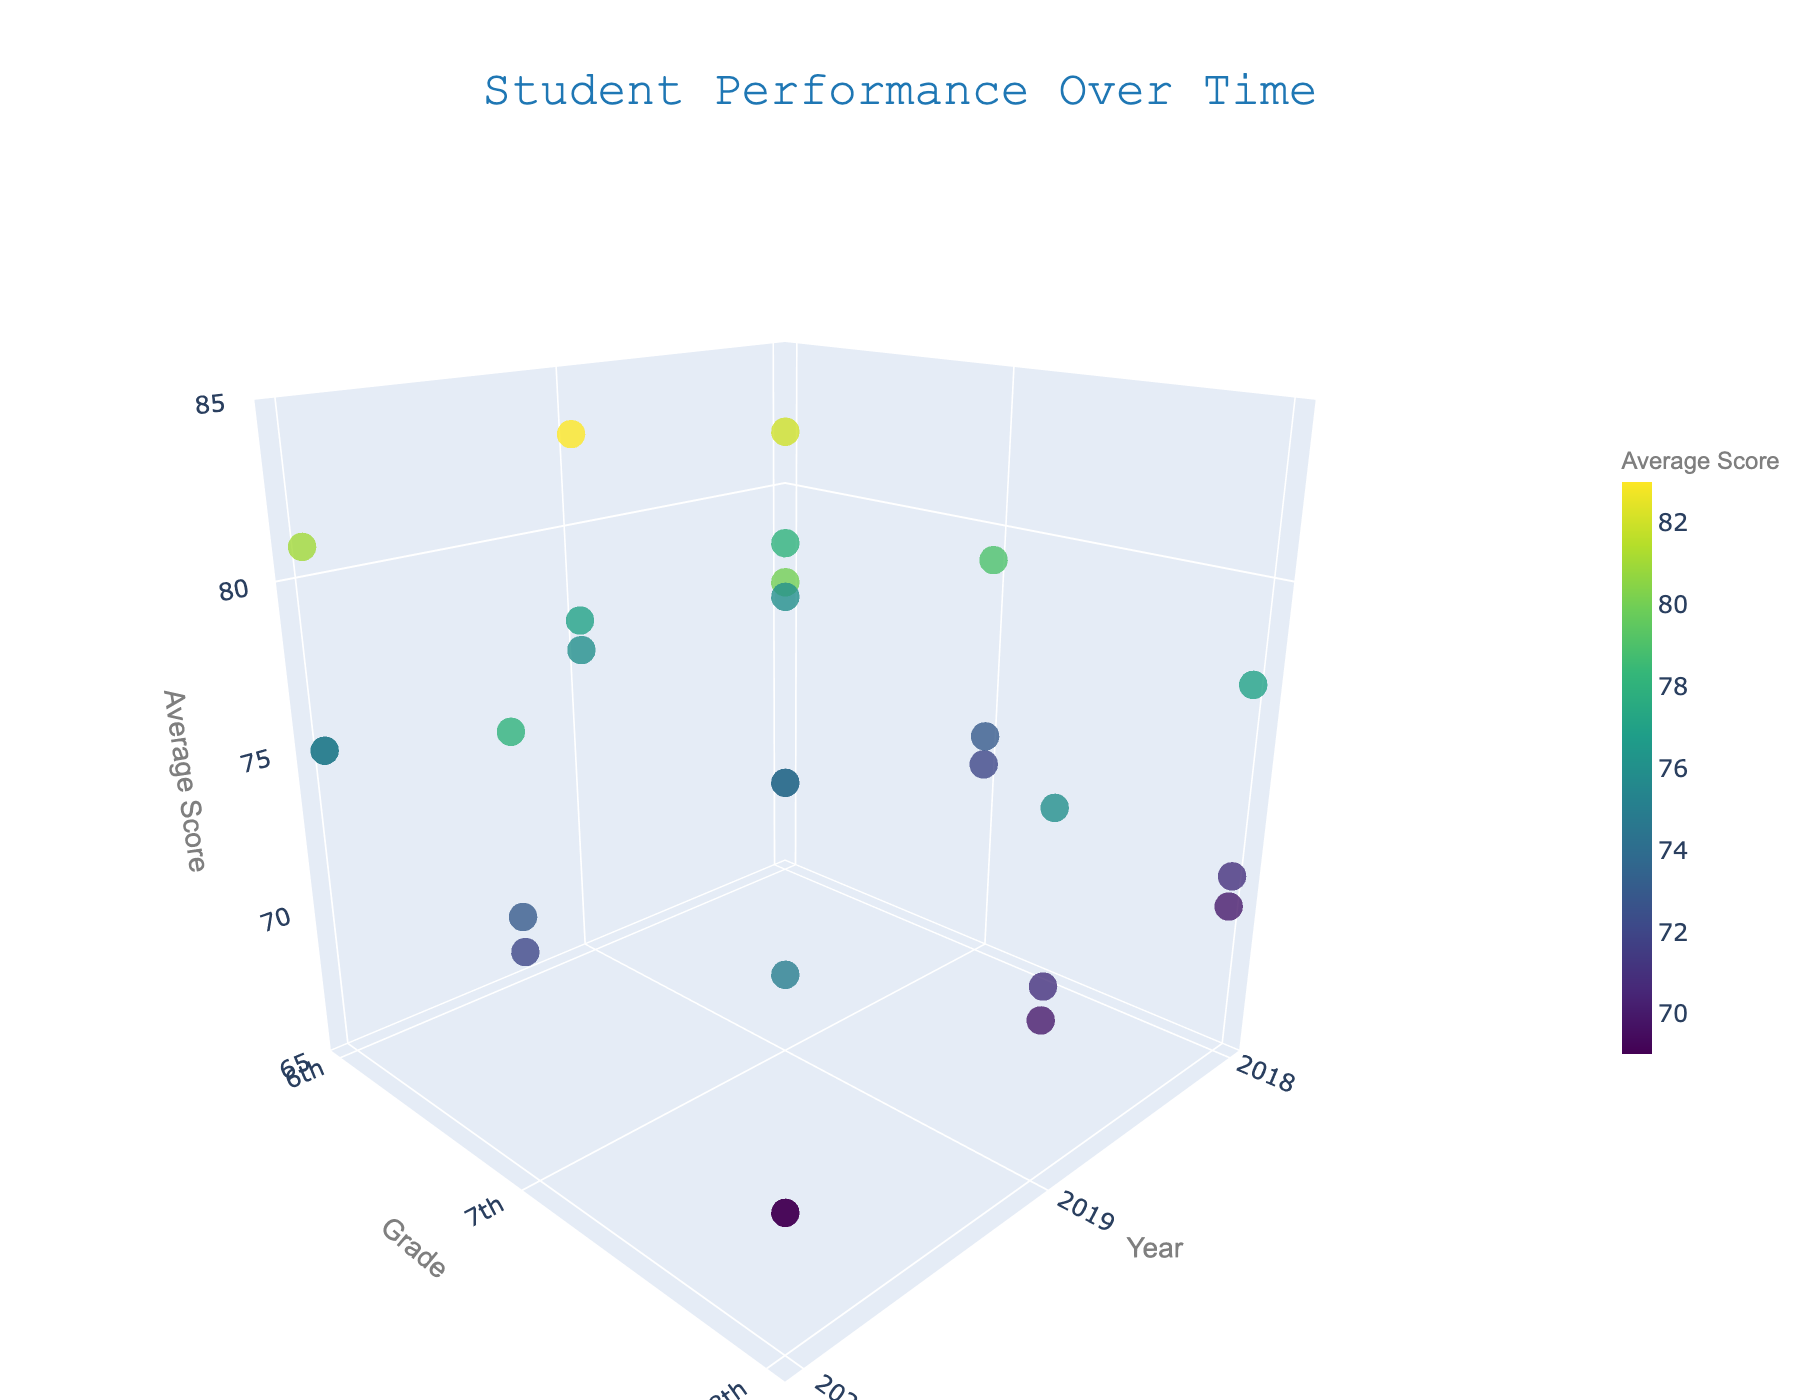How many unique grade levels are represented in the plot? The y-axis represents the grade levels, and we see tick values for 6th, 7th, and 8th grades.
Answer: 3 What color represents the highest average scores? The color scale on the markers uses Viridis, with lighter colors representing higher scores.
Answer: Light colors What is the overall trend in Mathematics scores across grades from 2018 to 2020? By observing the z-axis (Average Score) while tracking along the x-axis (Year) and y-axis (Grade) for Mathematics points, we see a slight decline in scores over years and grades.
Answer: Decline Which subject had the highest score in 2019 for 6th grade? By hovering over the relevant data points or observing the color coded by score, we see that English in 2019 for 6th grade has an average score of 83, which is the highest.
Answer: English How does the average score for Science change from 6th grade to 8th grade in 2020? Tracking the Science data points for 2020 along the y-axis from 6th to 8th grade, the scores decrease from 75 to 69.
Answer: Decrease Which year had the highest average scores across all subjects and grades? By extrapolating visual score points along the z-axis, 2018 appears to have the highest scores when considering all grades and subjects collectively.
Answer: 2018 Between which consecutive years did Mathematics scores change the most for 7th grade? By comparing the Mathematics points for 7th grade, the change between 2018-2019 is 2 points (72 to 74), while 2019-2020 shows a decrease of 1 point (74 to 73).
Answer: 2018-2019 Compare the performance of 8th-grade students in English versus Mathematics in 2020. For 2020, 8th-grade English has an average score of 75, and 8th-grade Mathematics has a score of 69.
Answer: English performs better 